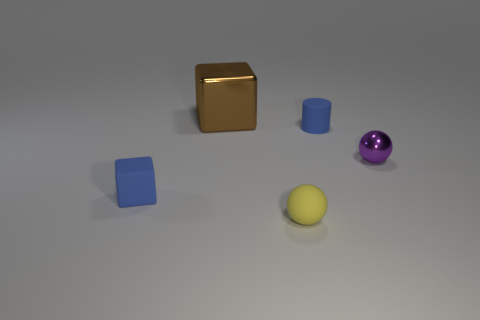There is a block that is in front of the purple object; is its color the same as the metallic thing that is to the right of the big cube?
Provide a succinct answer. No. Is the number of small shiny spheres to the left of the yellow matte object less than the number of big cubes that are right of the purple ball?
Your answer should be compact. No. Is there any other thing that is the same shape as the tiny shiny thing?
Provide a succinct answer. Yes. There is another object that is the same shape as the big brown thing; what is its color?
Ensure brevity in your answer.  Blue. Do the big brown object and the small blue rubber object that is to the right of the rubber sphere have the same shape?
Offer a terse response. No. What number of objects are big blocks that are behind the tiny blue rubber cylinder or matte objects on the right side of the tiny blue cube?
Provide a succinct answer. 3. What is the material of the brown block?
Provide a succinct answer. Metal. What number of other objects are there of the same size as the brown block?
Make the answer very short. 0. There is a blue block on the left side of the big brown shiny block; how big is it?
Make the answer very short. Small. What material is the cube that is in front of the shiny thing in front of the tiny blue thing behind the metal sphere?
Make the answer very short. Rubber. 